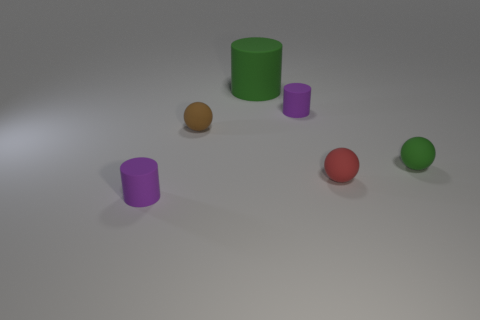Are there any big matte cylinders on the right side of the big thing?
Give a very brief answer. No. Do the green sphere and the green rubber cylinder have the same size?
Give a very brief answer. No. What number of large green cylinders are made of the same material as the small green ball?
Offer a very short reply. 1. What size is the purple cylinder that is behind the tiny rubber thing that is in front of the red thing?
Your answer should be compact. Small. There is a thing that is behind the red rubber sphere and to the left of the big green matte cylinder; what color is it?
Keep it short and to the point. Brown. Do the red object and the tiny brown matte thing have the same shape?
Ensure brevity in your answer.  Yes. What is the size of the sphere that is the same color as the big rubber thing?
Keep it short and to the point. Small. What is the shape of the purple matte object that is right of the small purple rubber cylinder that is in front of the tiny red thing?
Ensure brevity in your answer.  Cylinder. There is a red thing; is it the same shape as the tiny purple object on the left side of the big rubber thing?
Your answer should be very brief. No. Is the number of purple cylinders that are right of the small brown object less than the number of large green cylinders behind the large green rubber object?
Your answer should be compact. No. 